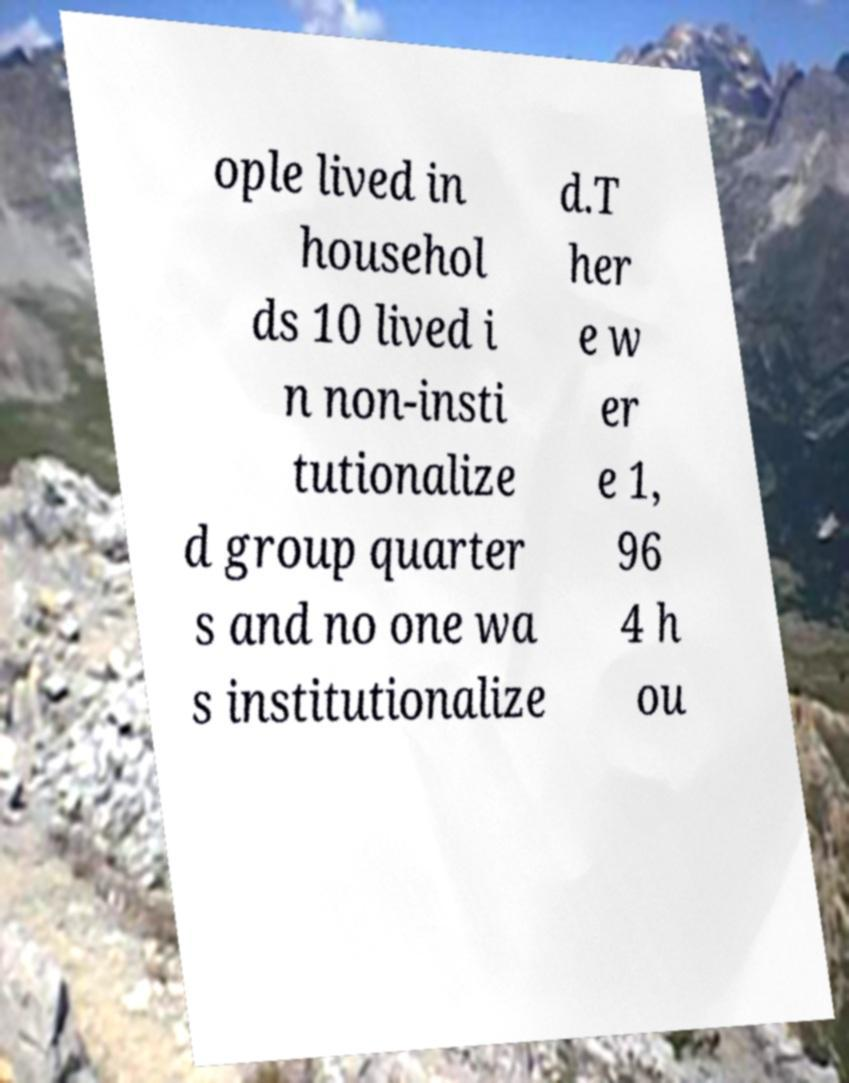I need the written content from this picture converted into text. Can you do that? ople lived in househol ds 10 lived i n non-insti tutionalize d group quarter s and no one wa s institutionalize d.T her e w er e 1, 96 4 h ou 